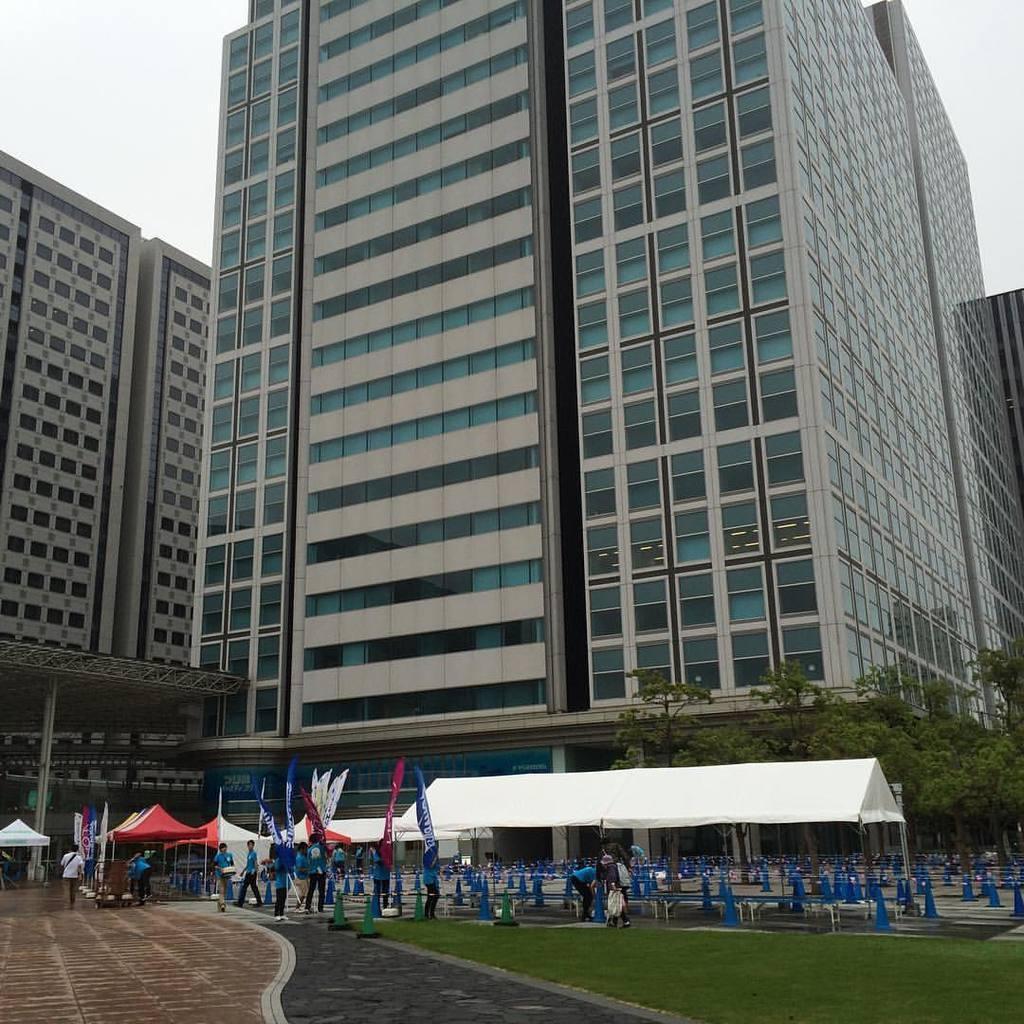Describe this image in one or two sentences. As we can see in the image there are buildings, trees, grass, benches, few people, flags and tents. At the top there is sky. 